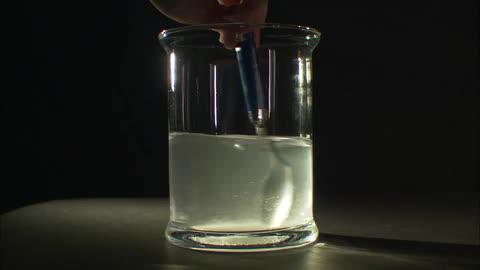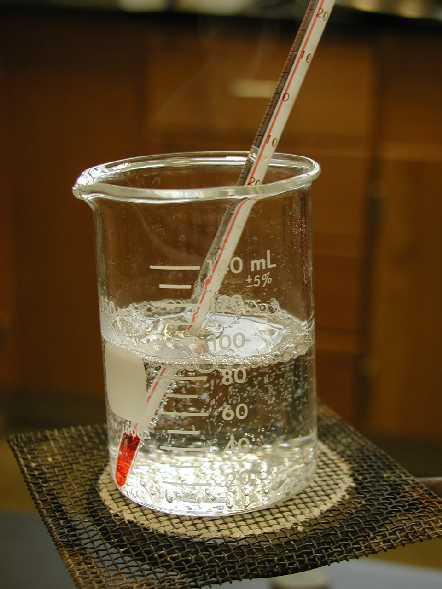The first image is the image on the left, the second image is the image on the right. Considering the images on both sides, is "The left image shows a cylindrical glass with liquid and a stirring spoon inside." valid? Answer yes or no. Yes. 